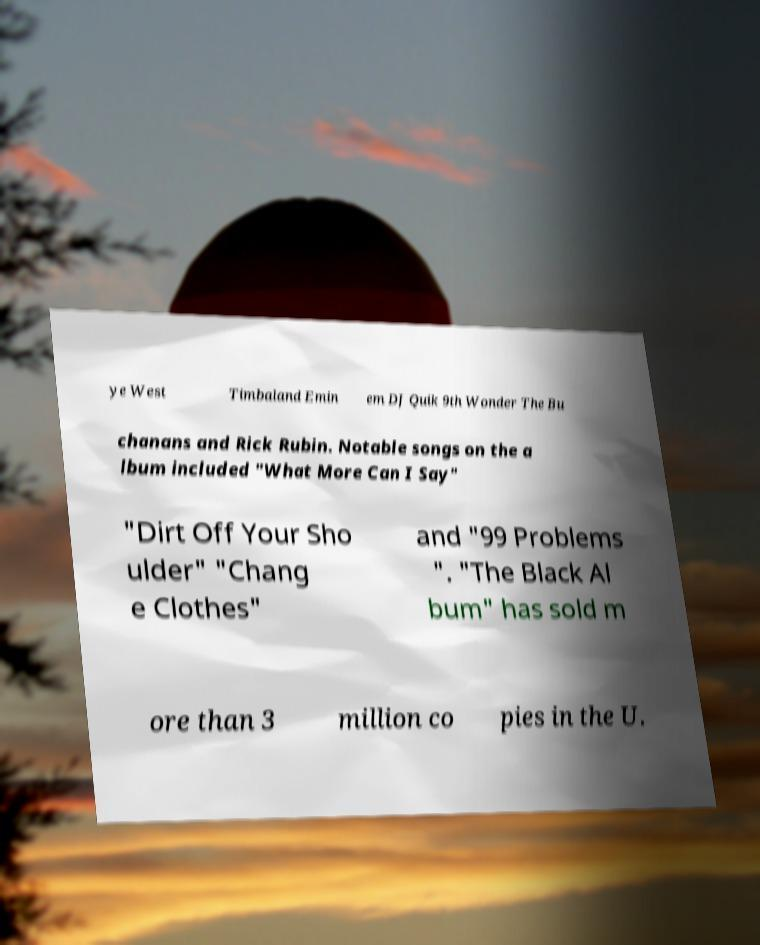There's text embedded in this image that I need extracted. Can you transcribe it verbatim? ye West Timbaland Emin em DJ Quik 9th Wonder The Bu chanans and Rick Rubin. Notable songs on the a lbum included "What More Can I Say" "Dirt Off Your Sho ulder" "Chang e Clothes" and "99 Problems ". "The Black Al bum" has sold m ore than 3 million co pies in the U. 